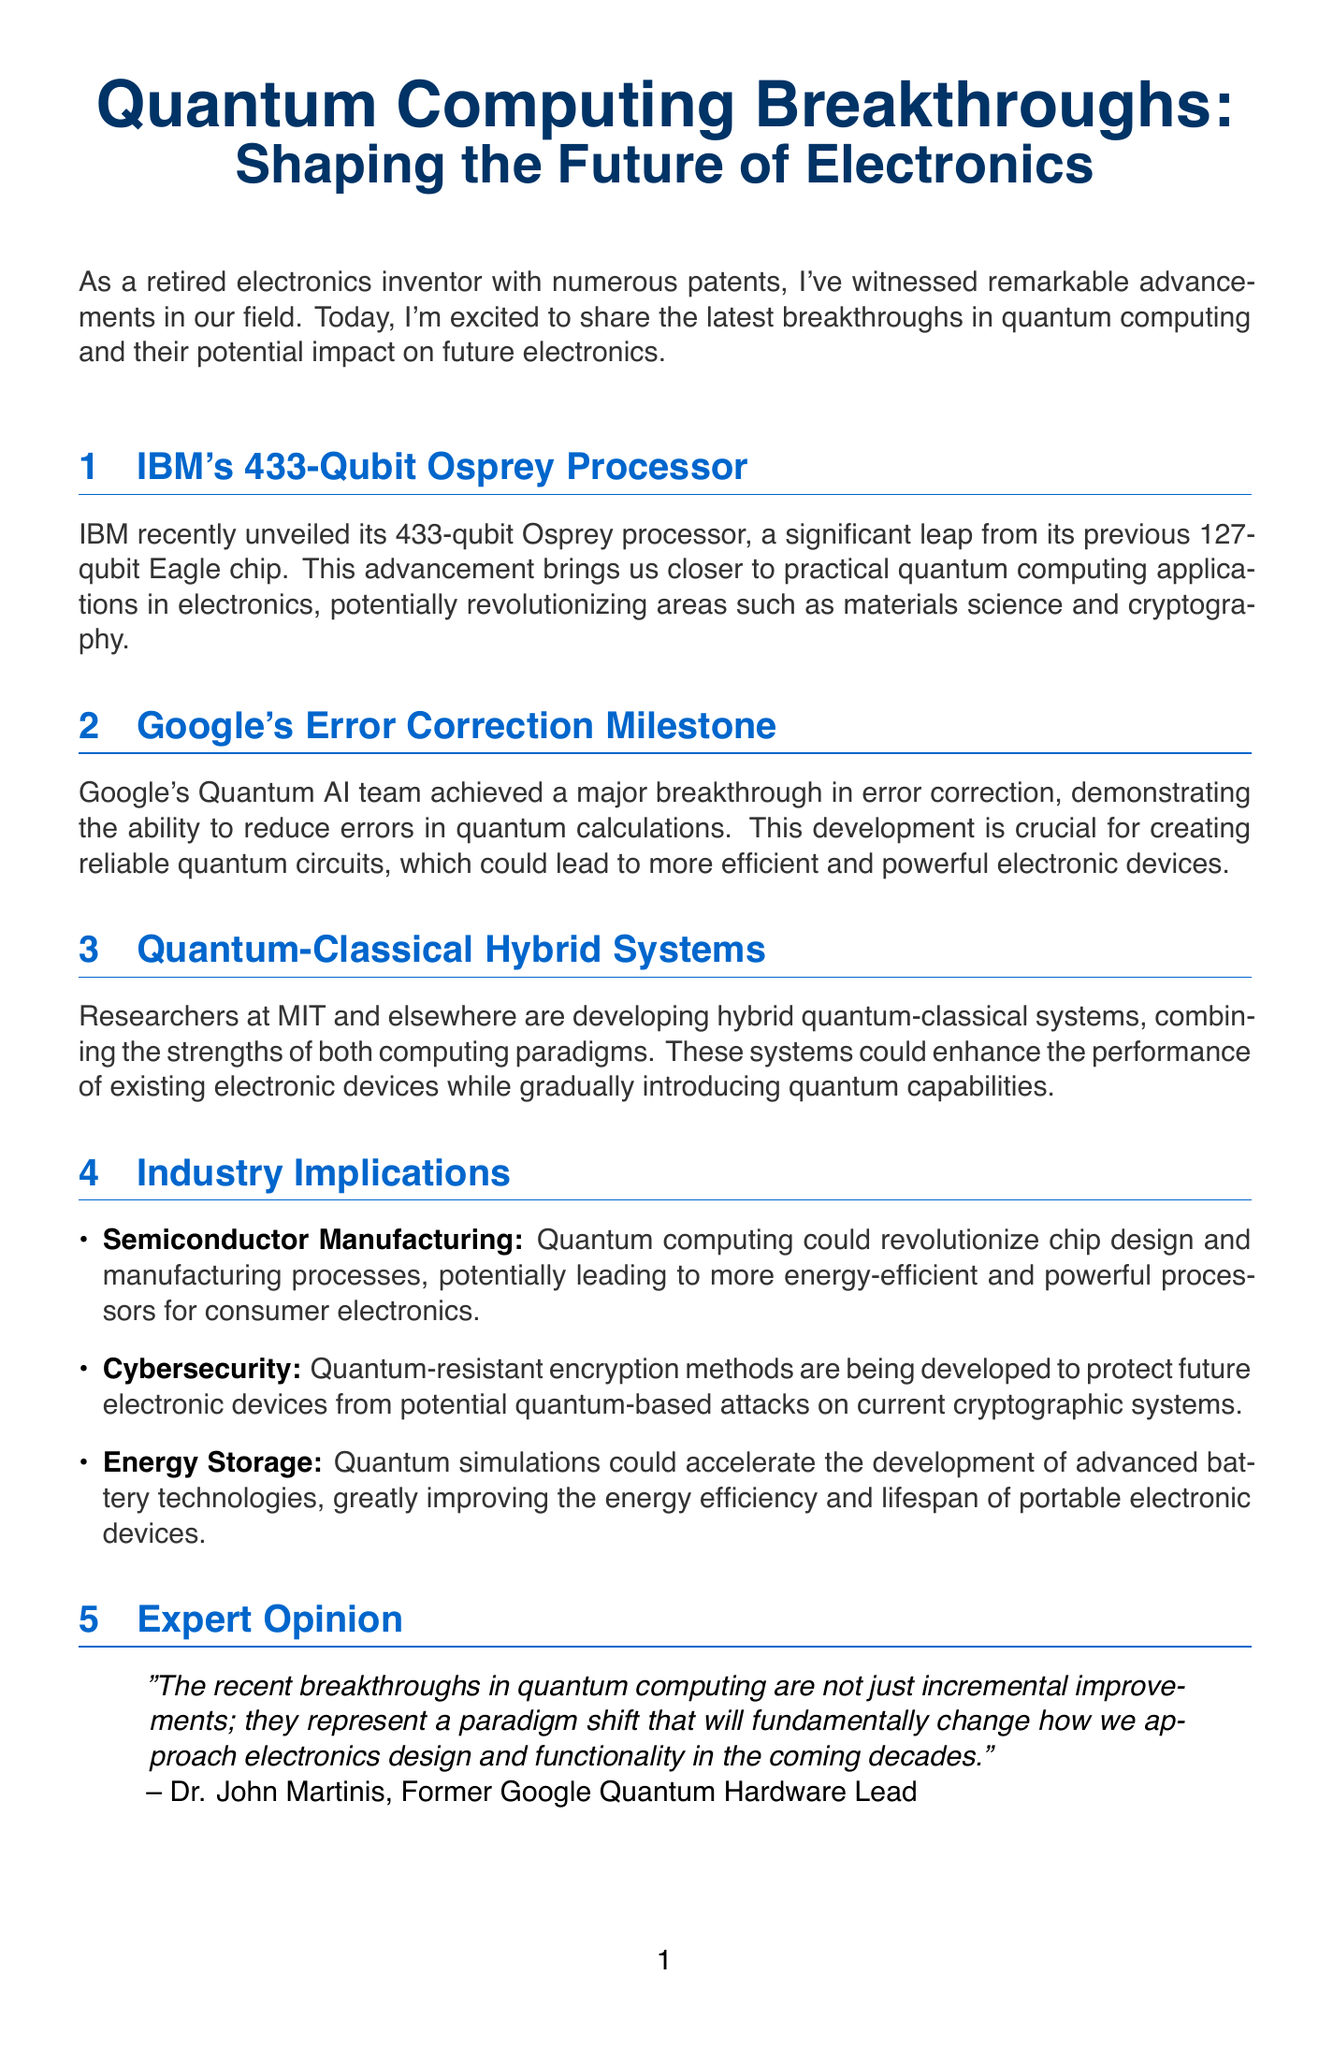What is the title of the newsletter? The title of the newsletter is provided at the beginning of the document.
Answer: Quantum Computing Breakthroughs: Shaping the Future of Electronics How many qubits does IBM's Osprey processor have? The document states the number of qubits in IBM's Osprey processor under its section.
Answer: 433-qubit What major milestone did Google's Quantum AI team achieve? The document highlights a specific achievement in error correction made by Google's Quantum AI team.
Answer: Error Correction Milestone What research is being done at MIT? The document mentions ongoing research at MIT in a specific area related to quantum computing.
Answer: Hybrid quantum-classical systems Who is the expert quoted in the newsletter? The document identifies the expert providing an opinion on the breakthroughs in quantum computing.
Answer: Dr. John Martinis What impact could quantum computing have on semiconductor manufacturing? The document explains the potential impact of quantum computing on a specific industry.
Answer: Revolutionize chip design and manufacturing processes What is the potential benefit of quantum simulations for energy storage? The document discusses a particular advantage related to energy storage technologies.
Answer: Accelerate the development of advanced battery technologies What sector is concerned with quantum-resistant encryption methods? The document specifies which sector is engaged in developing encryption methods in relation to quantum threats.
Answer: Cybersecurity 